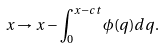Convert formula to latex. <formula><loc_0><loc_0><loc_500><loc_500>x \rightarrow x - \int _ { 0 } ^ { x - c t } \phi ( q ) d q .</formula> 